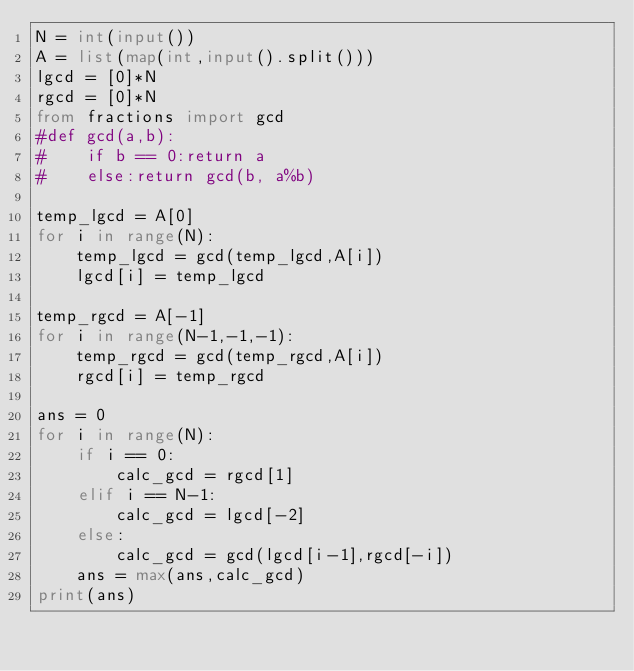Convert code to text. <code><loc_0><loc_0><loc_500><loc_500><_Python_>N = int(input())
A = list(map(int,input().split()))
lgcd = [0]*N
rgcd = [0]*N
from fractions import gcd
#def gcd(a,b):
#    if b == 0:return a
#    else:return gcd(b, a%b)

temp_lgcd = A[0]
for i in range(N):
    temp_lgcd = gcd(temp_lgcd,A[i])
    lgcd[i] = temp_lgcd

temp_rgcd = A[-1]
for i in range(N-1,-1,-1):
    temp_rgcd = gcd(temp_rgcd,A[i])
    rgcd[i] = temp_rgcd

ans = 0
for i in range(N):
    if i == 0:
        calc_gcd = rgcd[1]
    elif i == N-1:
        calc_gcd = lgcd[-2]
    else:
        calc_gcd = gcd(lgcd[i-1],rgcd[-i])
    ans = max(ans,calc_gcd)
print(ans)</code> 